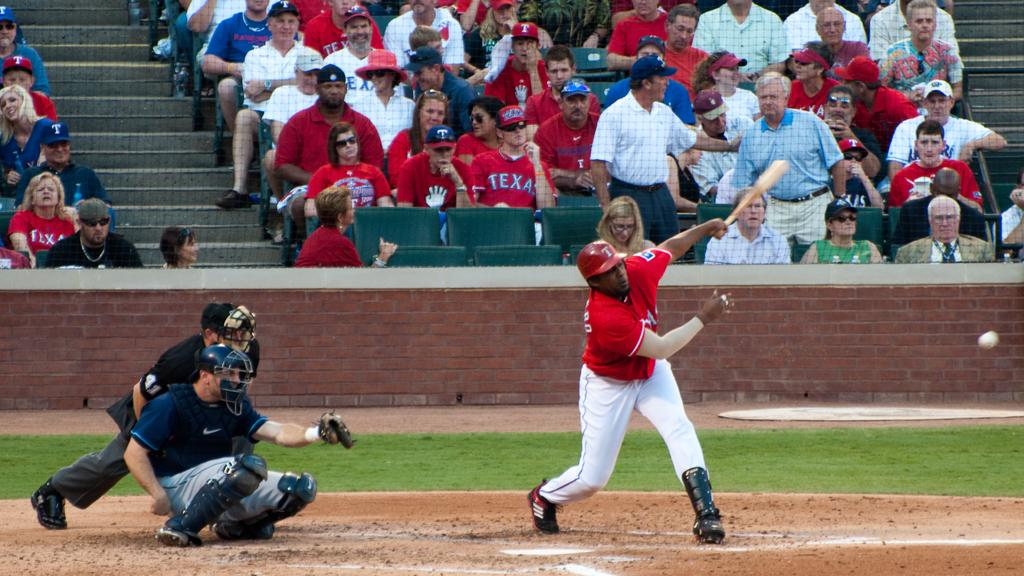<image>
Share a concise interpretation of the image provided. a baseball player with the texas logo on his shirt just swung his bat at a ball. 